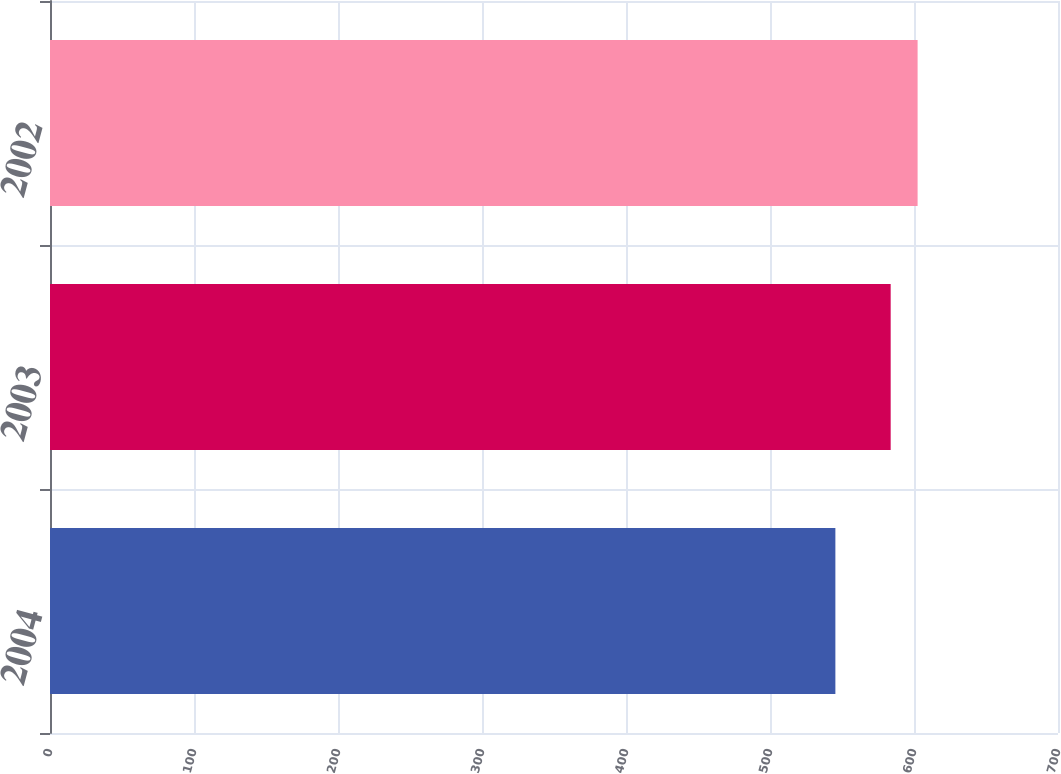<chart> <loc_0><loc_0><loc_500><loc_500><bar_chart><fcel>2004<fcel>2003<fcel>2002<nl><fcel>545.4<fcel>583.8<fcel>602.5<nl></chart> 